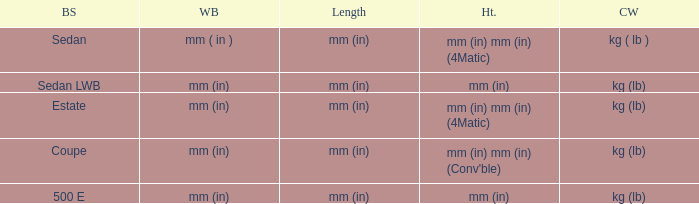Could you parse the entire table as a dict? {'header': ['BS', 'WB', 'Length', 'Ht.', 'CW'], 'rows': [['Sedan', 'mm ( in )', 'mm (in)', 'mm (in) mm (in) (4Matic)', 'kg ( lb )'], ['Sedan LWB', 'mm (in)', 'mm (in)', 'mm (in)', 'kg (lb)'], ['Estate', 'mm (in)', 'mm (in)', 'mm (in) mm (in) (4Matic)', 'kg (lb)'], ['Coupe', 'mm (in)', 'mm (in)', "mm (in) mm (in) (Conv'ble)", 'kg (lb)'], ['500 E', 'mm (in)', 'mm (in)', 'mm (in)', 'kg (lb)']]} What are the lengths of the models that are mm (in) tall? Mm (in), mm (in). 